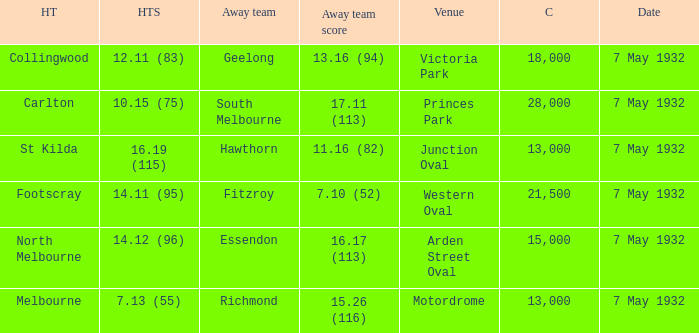How many people are in the crowd when the home team has a score of 14.12 (96)? 15000.0. 